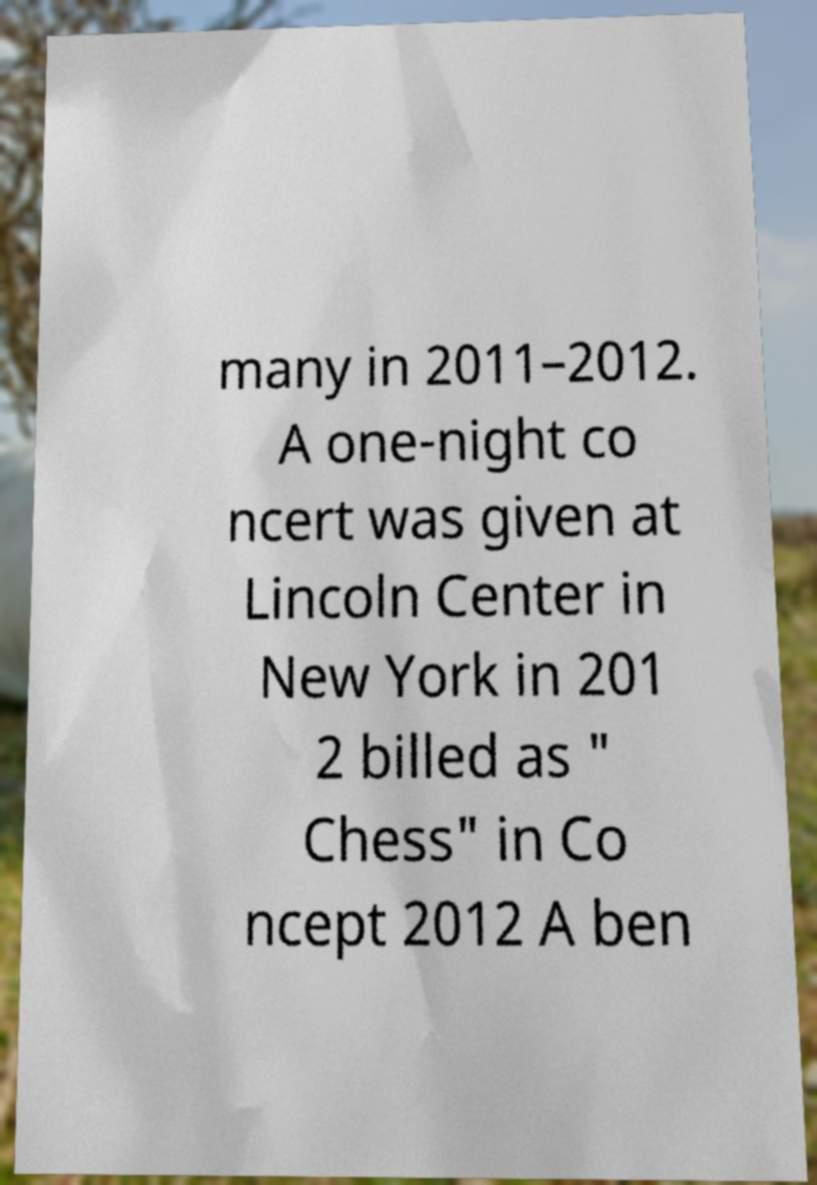There's text embedded in this image that I need extracted. Can you transcribe it verbatim? many in 2011–2012. A one-night co ncert was given at Lincoln Center in New York in 201 2 billed as " Chess" in Co ncept 2012 A ben 